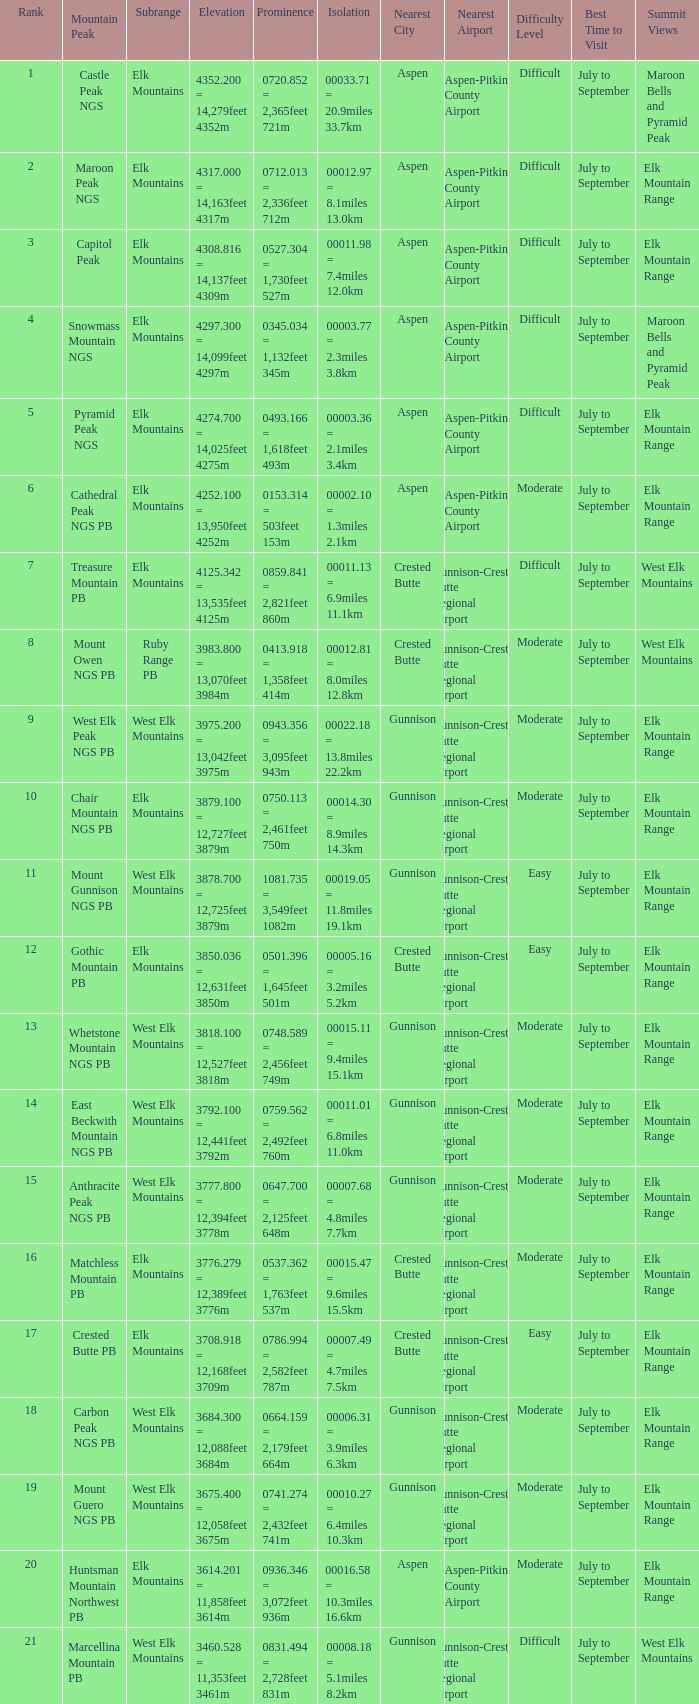Name the Rank of Rank Mountain Peak of crested butte pb? 17.0. 